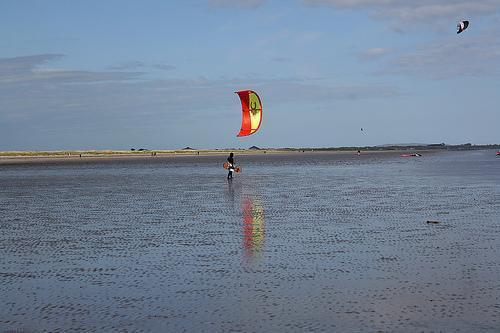How many sails are shown?
Give a very brief answer. 1. How many people can be seen?
Give a very brief answer. 1. 